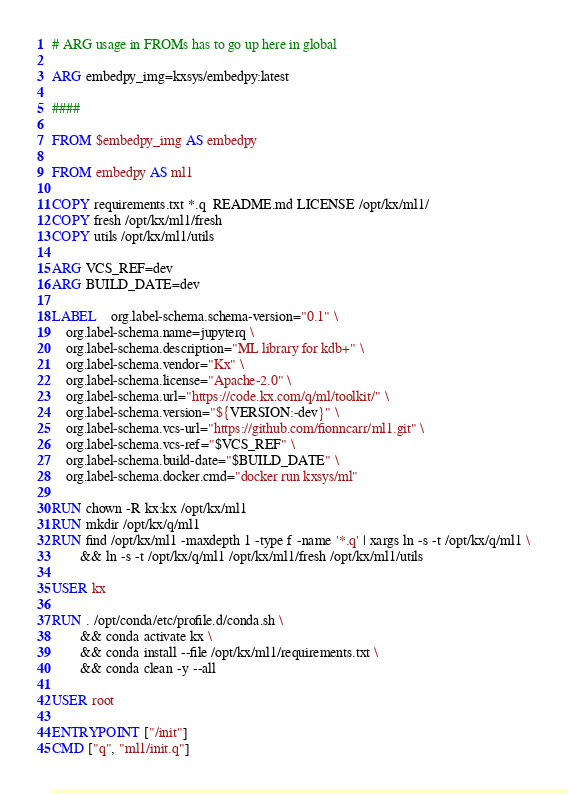<code> <loc_0><loc_0><loc_500><loc_500><_Dockerfile_># ARG usage in FROMs has to go up here in global

ARG embedpy_img=kxsys/embedpy:latest

####

FROM $embedpy_img AS embedpy

FROM embedpy AS ml1

COPY requirements.txt *.q  README.md LICENSE /opt/kx/ml1/
COPY fresh /opt/kx/ml1/fresh
COPY utils /opt/kx/ml1/utils

ARG VCS_REF=dev
ARG BUILD_DATE=dev

LABEL	org.label-schema.schema-version="0.1" \
	org.label-schema.name=jupyterq \
	org.label-schema.description="ML library for kdb+" \
	org.label-schema.vendor="Kx" \
	org.label-schema.license="Apache-2.0" \
	org.label-schema.url="https://code.kx.com/q/ml/toolkit/" \
	org.label-schema.version="${VERSION:-dev}" \
	org.label-schema.vcs-url="https://github.com/fionncarr/ml1.git" \
	org.label-schema.vcs-ref="$VCS_REF" \
	org.label-schema.build-date="$BUILD_DATE" \
	org.label-schema.docker.cmd="docker run kxsys/ml"

RUN chown -R kx:kx /opt/kx/ml1 
RUN mkdir /opt/kx/q/ml1
RUN find /opt/kx/ml1 -maxdepth 1 -type f -name '*.q' | xargs ln -s -t /opt/kx/q/ml1 \
        && ln -s -t /opt/kx/q/ml1 /opt/kx/ml1/fresh /opt/kx/ml1/utils

USER kx

RUN . /opt/conda/etc/profile.d/conda.sh \
        && conda activate kx \
        && conda install --file /opt/kx/ml1/requirements.txt \
        && conda clean -y --all 

USER root

ENTRYPOINT ["/init"]
CMD ["q", "ml1/init.q"]
</code> 